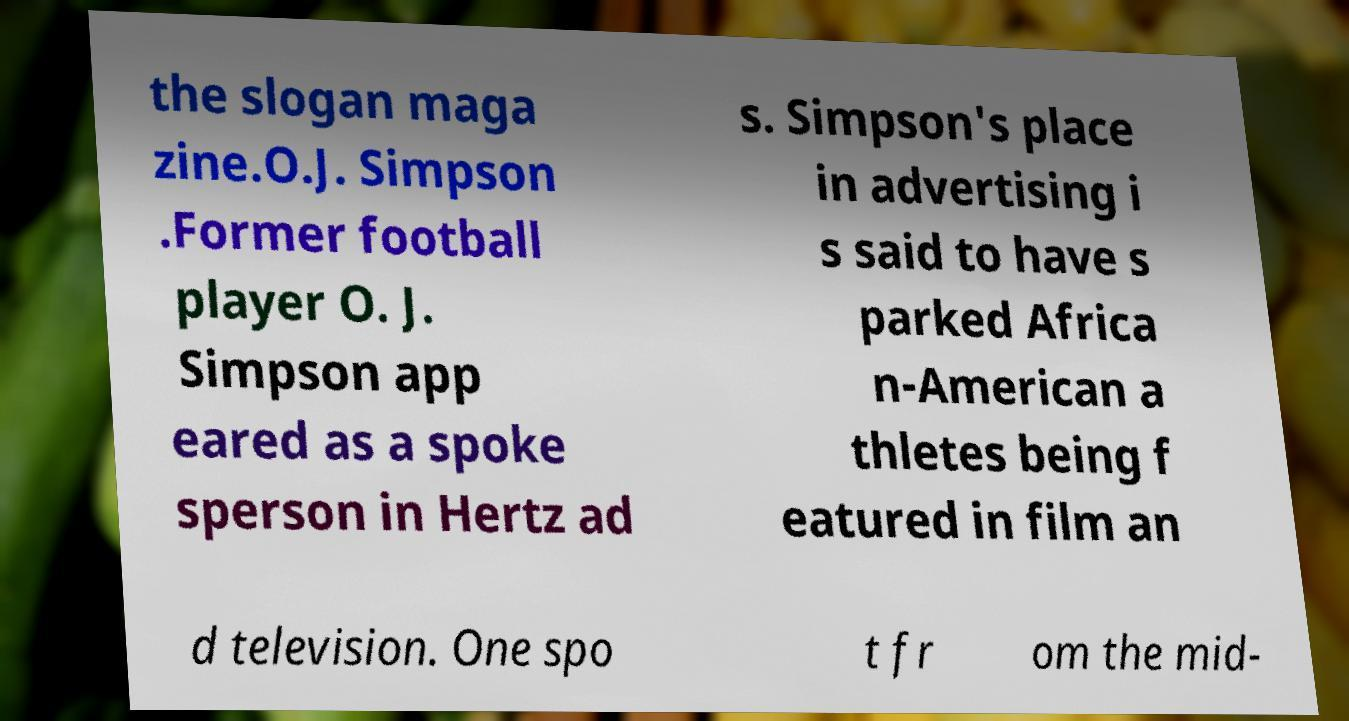Please identify and transcribe the text found in this image. the slogan maga zine.O.J. Simpson .Former football player O. J. Simpson app eared as a spoke sperson in Hertz ad s. Simpson's place in advertising i s said to have s parked Africa n-American a thletes being f eatured in film an d television. One spo t fr om the mid- 